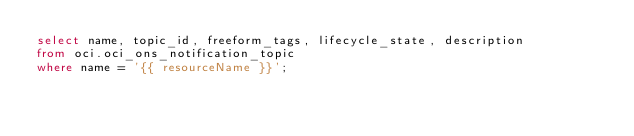<code> <loc_0><loc_0><loc_500><loc_500><_SQL_>select name, topic_id, freeform_tags, lifecycle_state, description
from oci.oci_ons_notification_topic
where name = '{{ resourceName }}';</code> 